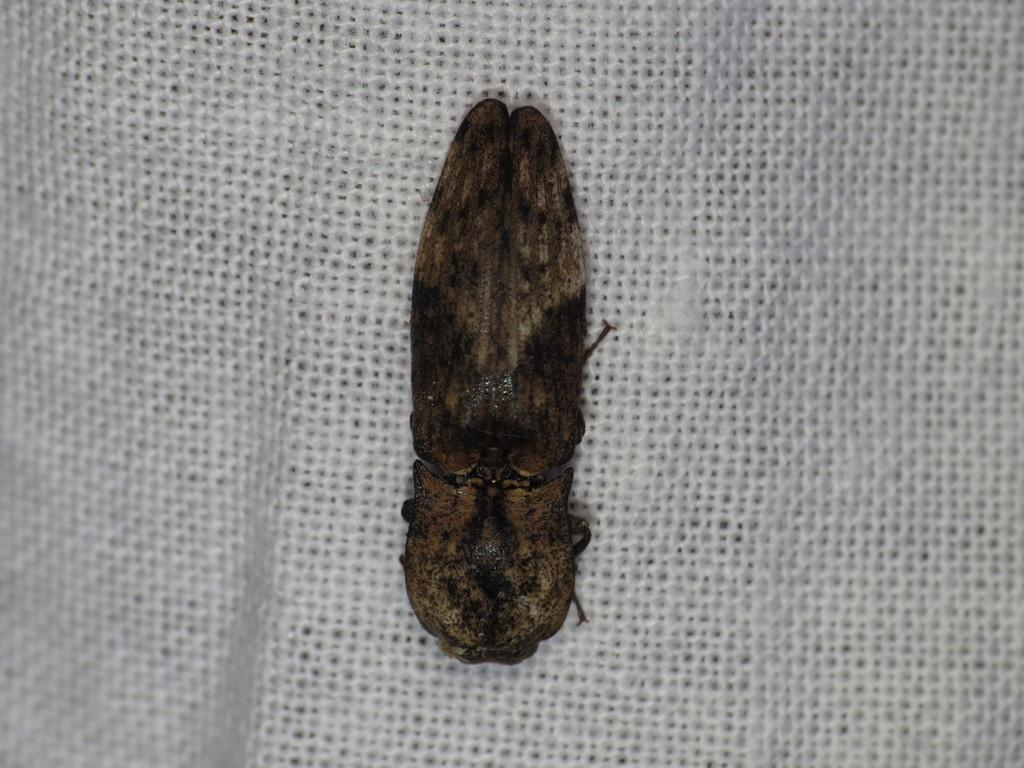What type of creature is in the image? There is an insect in the image. What is the background of the insect in the image? The insect is on a white surface. Where is the insect located in relation to the image? The insect is in the foreground of the image. What type of curve can be seen on the branch in the image? There is no branch or curve present in the image; it features an insect on a white surface. 